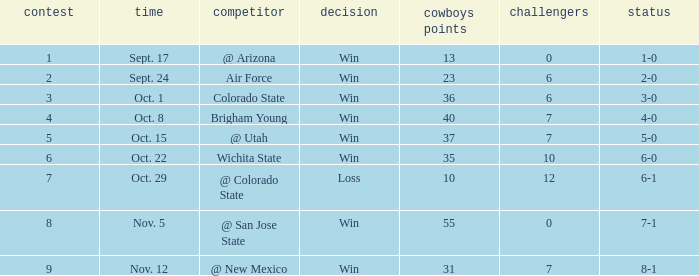What was the Cowboys' record for Nov. 5, 1966? 7-1. 